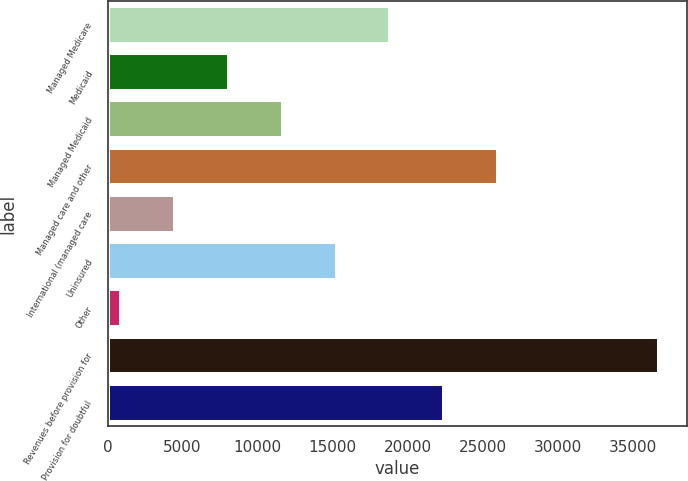<chart> <loc_0><loc_0><loc_500><loc_500><bar_chart><fcel>Managed Medicare<fcel>Medicaid<fcel>Managed Medicaid<fcel>Managed care and other<fcel>International (managed care<fcel>Uninsured<fcel>Other<fcel>Revenues before provision for<fcel>Provision for doubtful<nl><fcel>18857<fcel>8101.4<fcel>11686.6<fcel>26027.4<fcel>4516.2<fcel>15271.8<fcel>931<fcel>36783<fcel>22442.2<nl></chart> 